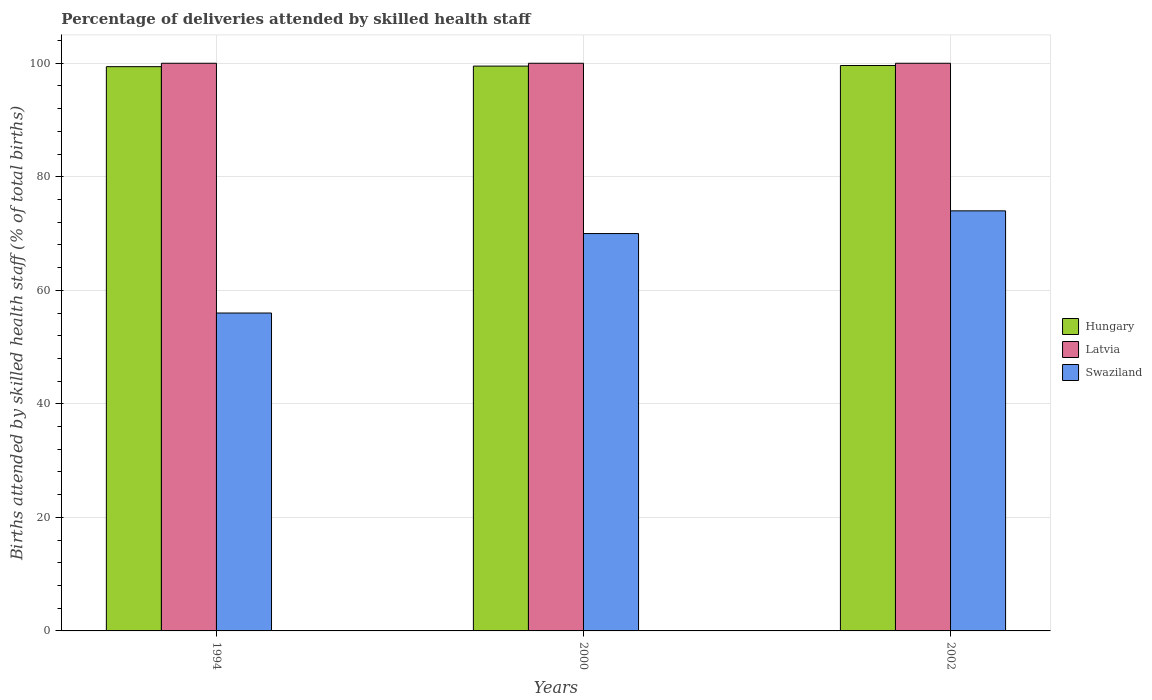How many groups of bars are there?
Provide a short and direct response. 3. How many bars are there on the 3rd tick from the right?
Give a very brief answer. 3. What is the label of the 3rd group of bars from the left?
Keep it short and to the point. 2002. What is the percentage of births attended by skilled health staff in Latvia in 2000?
Provide a succinct answer. 100. Across all years, what is the minimum percentage of births attended by skilled health staff in Hungary?
Your answer should be very brief. 99.4. In which year was the percentage of births attended by skilled health staff in Hungary maximum?
Provide a succinct answer. 2002. What is the total percentage of births attended by skilled health staff in Hungary in the graph?
Provide a succinct answer. 298.5. What is the difference between the percentage of births attended by skilled health staff in Latvia in 1994 and that in 2000?
Your response must be concise. 0. What is the difference between the percentage of births attended by skilled health staff in Hungary in 2002 and the percentage of births attended by skilled health staff in Latvia in 1994?
Keep it short and to the point. -0.4. What is the average percentage of births attended by skilled health staff in Swaziland per year?
Make the answer very short. 66.67. In the year 2000, what is the difference between the percentage of births attended by skilled health staff in Hungary and percentage of births attended by skilled health staff in Swaziland?
Ensure brevity in your answer.  29.5. In how many years, is the percentage of births attended by skilled health staff in Hungary greater than 48 %?
Make the answer very short. 3. What is the ratio of the percentage of births attended by skilled health staff in Latvia in 1994 to that in 2002?
Offer a terse response. 1. What is the difference between the highest and the lowest percentage of births attended by skilled health staff in Hungary?
Provide a succinct answer. 0.2. In how many years, is the percentage of births attended by skilled health staff in Hungary greater than the average percentage of births attended by skilled health staff in Hungary taken over all years?
Provide a short and direct response. 1. What does the 3rd bar from the left in 2000 represents?
Keep it short and to the point. Swaziland. What does the 2nd bar from the right in 2002 represents?
Offer a very short reply. Latvia. Is it the case that in every year, the sum of the percentage of births attended by skilled health staff in Latvia and percentage of births attended by skilled health staff in Hungary is greater than the percentage of births attended by skilled health staff in Swaziland?
Provide a short and direct response. Yes. How many bars are there?
Offer a very short reply. 9. Are all the bars in the graph horizontal?
Ensure brevity in your answer.  No. How many years are there in the graph?
Give a very brief answer. 3. What is the difference between two consecutive major ticks on the Y-axis?
Your answer should be very brief. 20. Does the graph contain any zero values?
Your answer should be compact. No. Does the graph contain grids?
Provide a short and direct response. Yes. Where does the legend appear in the graph?
Offer a very short reply. Center right. How many legend labels are there?
Your answer should be very brief. 3. How are the legend labels stacked?
Provide a succinct answer. Vertical. What is the title of the graph?
Your answer should be very brief. Percentage of deliveries attended by skilled health staff. Does "Ghana" appear as one of the legend labels in the graph?
Give a very brief answer. No. What is the label or title of the X-axis?
Offer a very short reply. Years. What is the label or title of the Y-axis?
Make the answer very short. Births attended by skilled health staff (% of total births). What is the Births attended by skilled health staff (% of total births) in Hungary in 1994?
Offer a terse response. 99.4. What is the Births attended by skilled health staff (% of total births) of Hungary in 2000?
Ensure brevity in your answer.  99.5. What is the Births attended by skilled health staff (% of total births) in Hungary in 2002?
Your answer should be compact. 99.6. What is the Births attended by skilled health staff (% of total births) of Swaziland in 2002?
Make the answer very short. 74. Across all years, what is the maximum Births attended by skilled health staff (% of total births) in Hungary?
Offer a very short reply. 99.6. Across all years, what is the maximum Births attended by skilled health staff (% of total births) of Latvia?
Offer a terse response. 100. Across all years, what is the minimum Births attended by skilled health staff (% of total births) of Hungary?
Your answer should be very brief. 99.4. Across all years, what is the minimum Births attended by skilled health staff (% of total births) of Swaziland?
Make the answer very short. 56. What is the total Births attended by skilled health staff (% of total births) of Hungary in the graph?
Offer a terse response. 298.5. What is the total Births attended by skilled health staff (% of total births) in Latvia in the graph?
Your answer should be compact. 300. What is the total Births attended by skilled health staff (% of total births) in Swaziland in the graph?
Offer a terse response. 200. What is the difference between the Births attended by skilled health staff (% of total births) of Swaziland in 1994 and that in 2000?
Your answer should be compact. -14. What is the difference between the Births attended by skilled health staff (% of total births) in Hungary in 1994 and that in 2002?
Make the answer very short. -0.2. What is the difference between the Births attended by skilled health staff (% of total births) of Swaziland in 1994 and that in 2002?
Make the answer very short. -18. What is the difference between the Births attended by skilled health staff (% of total births) of Swaziland in 2000 and that in 2002?
Keep it short and to the point. -4. What is the difference between the Births attended by skilled health staff (% of total births) of Hungary in 1994 and the Births attended by skilled health staff (% of total births) of Latvia in 2000?
Make the answer very short. -0.6. What is the difference between the Births attended by skilled health staff (% of total births) in Hungary in 1994 and the Births attended by skilled health staff (% of total births) in Swaziland in 2000?
Provide a short and direct response. 29.4. What is the difference between the Births attended by skilled health staff (% of total births) of Hungary in 1994 and the Births attended by skilled health staff (% of total births) of Latvia in 2002?
Offer a terse response. -0.6. What is the difference between the Births attended by skilled health staff (% of total births) of Hungary in 1994 and the Births attended by skilled health staff (% of total births) of Swaziland in 2002?
Your answer should be compact. 25.4. What is the difference between the Births attended by skilled health staff (% of total births) of Latvia in 1994 and the Births attended by skilled health staff (% of total births) of Swaziland in 2002?
Make the answer very short. 26. What is the difference between the Births attended by skilled health staff (% of total births) in Hungary in 2000 and the Births attended by skilled health staff (% of total births) in Swaziland in 2002?
Make the answer very short. 25.5. What is the difference between the Births attended by skilled health staff (% of total births) of Latvia in 2000 and the Births attended by skilled health staff (% of total births) of Swaziland in 2002?
Your answer should be very brief. 26. What is the average Births attended by skilled health staff (% of total births) in Hungary per year?
Provide a succinct answer. 99.5. What is the average Births attended by skilled health staff (% of total births) in Swaziland per year?
Ensure brevity in your answer.  66.67. In the year 1994, what is the difference between the Births attended by skilled health staff (% of total births) in Hungary and Births attended by skilled health staff (% of total births) in Swaziland?
Offer a terse response. 43.4. In the year 2000, what is the difference between the Births attended by skilled health staff (% of total births) in Hungary and Births attended by skilled health staff (% of total births) in Swaziland?
Offer a very short reply. 29.5. In the year 2002, what is the difference between the Births attended by skilled health staff (% of total births) in Hungary and Births attended by skilled health staff (% of total births) in Latvia?
Offer a very short reply. -0.4. In the year 2002, what is the difference between the Births attended by skilled health staff (% of total births) of Hungary and Births attended by skilled health staff (% of total births) of Swaziland?
Make the answer very short. 25.6. What is the ratio of the Births attended by skilled health staff (% of total births) in Hungary in 1994 to that in 2000?
Give a very brief answer. 1. What is the ratio of the Births attended by skilled health staff (% of total births) of Hungary in 1994 to that in 2002?
Ensure brevity in your answer.  1. What is the ratio of the Births attended by skilled health staff (% of total births) of Latvia in 1994 to that in 2002?
Your answer should be compact. 1. What is the ratio of the Births attended by skilled health staff (% of total births) in Swaziland in 1994 to that in 2002?
Ensure brevity in your answer.  0.76. What is the ratio of the Births attended by skilled health staff (% of total births) in Hungary in 2000 to that in 2002?
Provide a succinct answer. 1. What is the ratio of the Births attended by skilled health staff (% of total births) in Swaziland in 2000 to that in 2002?
Offer a very short reply. 0.95. What is the difference between the highest and the second highest Births attended by skilled health staff (% of total births) of Hungary?
Your answer should be compact. 0.1. What is the difference between the highest and the second highest Births attended by skilled health staff (% of total births) of Latvia?
Your answer should be very brief. 0. What is the difference between the highest and the second highest Births attended by skilled health staff (% of total births) of Swaziland?
Your response must be concise. 4. 